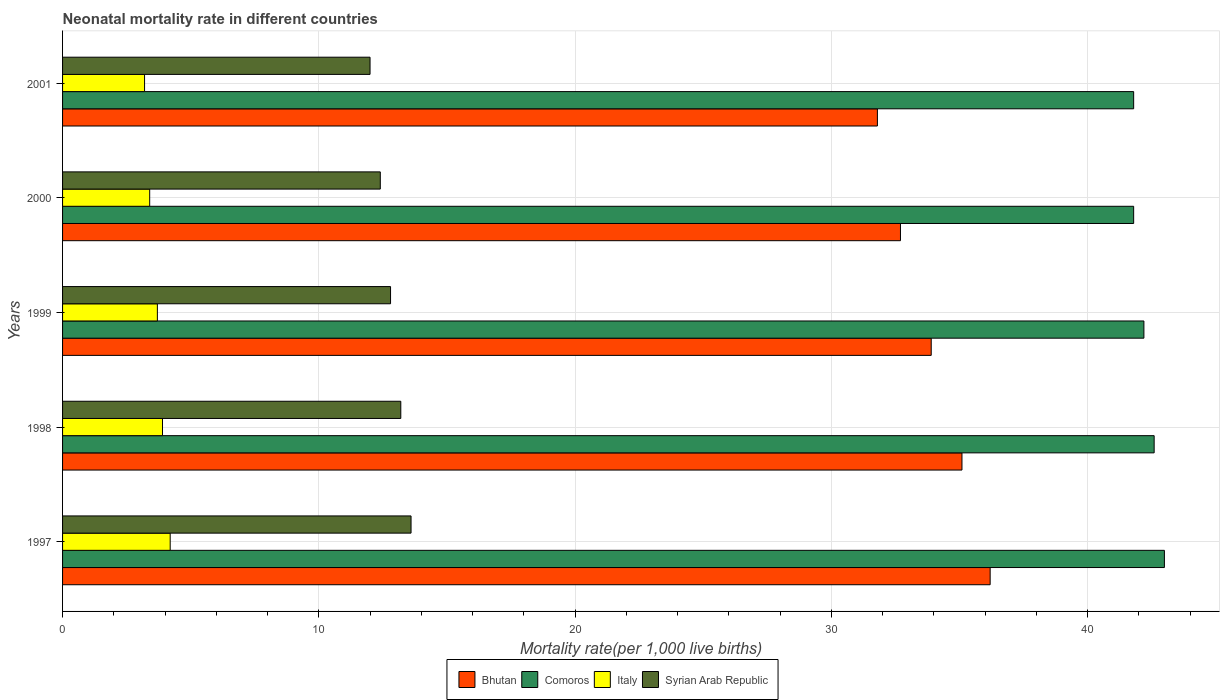How many different coloured bars are there?
Your answer should be very brief. 4. How many groups of bars are there?
Offer a very short reply. 5. Are the number of bars per tick equal to the number of legend labels?
Provide a short and direct response. Yes. How many bars are there on the 3rd tick from the bottom?
Give a very brief answer. 4. What is the label of the 2nd group of bars from the top?
Provide a succinct answer. 2000. What is the neonatal mortality rate in Comoros in 2001?
Keep it short and to the point. 41.8. Across all years, what is the maximum neonatal mortality rate in Italy?
Ensure brevity in your answer.  4.2. Across all years, what is the minimum neonatal mortality rate in Bhutan?
Your response must be concise. 31.8. In which year was the neonatal mortality rate in Syrian Arab Republic maximum?
Give a very brief answer. 1997. In which year was the neonatal mortality rate in Italy minimum?
Ensure brevity in your answer.  2001. What is the total neonatal mortality rate in Comoros in the graph?
Ensure brevity in your answer.  211.4. What is the difference between the neonatal mortality rate in Bhutan in 1997 and that in 1999?
Give a very brief answer. 2.3. What is the difference between the neonatal mortality rate in Bhutan in 1997 and the neonatal mortality rate in Syrian Arab Republic in 2001?
Give a very brief answer. 24.2. What is the average neonatal mortality rate in Syrian Arab Republic per year?
Ensure brevity in your answer.  12.8. In the year 1998, what is the difference between the neonatal mortality rate in Bhutan and neonatal mortality rate in Comoros?
Your response must be concise. -7.5. What is the ratio of the neonatal mortality rate in Comoros in 1998 to that in 2001?
Ensure brevity in your answer.  1.02. What is the difference between the highest and the second highest neonatal mortality rate in Bhutan?
Provide a short and direct response. 1.1. What is the difference between the highest and the lowest neonatal mortality rate in Comoros?
Offer a very short reply. 1.2. In how many years, is the neonatal mortality rate in Syrian Arab Republic greater than the average neonatal mortality rate in Syrian Arab Republic taken over all years?
Make the answer very short. 3. What does the 1st bar from the top in 1998 represents?
Offer a terse response. Syrian Arab Republic. What does the 1st bar from the bottom in 2001 represents?
Your response must be concise. Bhutan. How many bars are there?
Keep it short and to the point. 20. Are all the bars in the graph horizontal?
Provide a succinct answer. Yes. Are the values on the major ticks of X-axis written in scientific E-notation?
Keep it short and to the point. No. Does the graph contain grids?
Make the answer very short. Yes. Where does the legend appear in the graph?
Make the answer very short. Bottom center. What is the title of the graph?
Offer a terse response. Neonatal mortality rate in different countries. Does "Moldova" appear as one of the legend labels in the graph?
Offer a very short reply. No. What is the label or title of the X-axis?
Make the answer very short. Mortality rate(per 1,0 live births). What is the label or title of the Y-axis?
Make the answer very short. Years. What is the Mortality rate(per 1,000 live births) of Bhutan in 1997?
Make the answer very short. 36.2. What is the Mortality rate(per 1,000 live births) in Italy in 1997?
Give a very brief answer. 4.2. What is the Mortality rate(per 1,000 live births) of Syrian Arab Republic in 1997?
Your answer should be compact. 13.6. What is the Mortality rate(per 1,000 live births) of Bhutan in 1998?
Give a very brief answer. 35.1. What is the Mortality rate(per 1,000 live births) of Comoros in 1998?
Give a very brief answer. 42.6. What is the Mortality rate(per 1,000 live births) of Italy in 1998?
Ensure brevity in your answer.  3.9. What is the Mortality rate(per 1,000 live births) of Bhutan in 1999?
Offer a very short reply. 33.9. What is the Mortality rate(per 1,000 live births) in Comoros in 1999?
Your answer should be very brief. 42.2. What is the Mortality rate(per 1,000 live births) of Syrian Arab Republic in 1999?
Provide a short and direct response. 12.8. What is the Mortality rate(per 1,000 live births) in Bhutan in 2000?
Your answer should be compact. 32.7. What is the Mortality rate(per 1,000 live births) of Comoros in 2000?
Make the answer very short. 41.8. What is the Mortality rate(per 1,000 live births) in Italy in 2000?
Ensure brevity in your answer.  3.4. What is the Mortality rate(per 1,000 live births) in Bhutan in 2001?
Give a very brief answer. 31.8. What is the Mortality rate(per 1,000 live births) of Comoros in 2001?
Make the answer very short. 41.8. What is the Mortality rate(per 1,000 live births) in Syrian Arab Republic in 2001?
Provide a succinct answer. 12. Across all years, what is the maximum Mortality rate(per 1,000 live births) in Bhutan?
Provide a short and direct response. 36.2. Across all years, what is the maximum Mortality rate(per 1,000 live births) in Comoros?
Your response must be concise. 43. Across all years, what is the maximum Mortality rate(per 1,000 live births) in Italy?
Your answer should be very brief. 4.2. Across all years, what is the minimum Mortality rate(per 1,000 live births) of Bhutan?
Your response must be concise. 31.8. Across all years, what is the minimum Mortality rate(per 1,000 live births) in Comoros?
Give a very brief answer. 41.8. What is the total Mortality rate(per 1,000 live births) in Bhutan in the graph?
Keep it short and to the point. 169.7. What is the total Mortality rate(per 1,000 live births) in Comoros in the graph?
Keep it short and to the point. 211.4. What is the total Mortality rate(per 1,000 live births) in Syrian Arab Republic in the graph?
Offer a very short reply. 64. What is the difference between the Mortality rate(per 1,000 live births) of Syrian Arab Republic in 1997 and that in 1998?
Make the answer very short. 0.4. What is the difference between the Mortality rate(per 1,000 live births) of Comoros in 1997 and that in 1999?
Offer a very short reply. 0.8. What is the difference between the Mortality rate(per 1,000 live births) in Bhutan in 1997 and that in 2000?
Offer a very short reply. 3.5. What is the difference between the Mortality rate(per 1,000 live births) of Comoros in 1997 and that in 2000?
Provide a succinct answer. 1.2. What is the difference between the Mortality rate(per 1,000 live births) of Italy in 1997 and that in 2001?
Your answer should be compact. 1. What is the difference between the Mortality rate(per 1,000 live births) of Italy in 1998 and that in 1999?
Your response must be concise. 0.2. What is the difference between the Mortality rate(per 1,000 live births) in Syrian Arab Republic in 1998 and that in 1999?
Your answer should be very brief. 0.4. What is the difference between the Mortality rate(per 1,000 live births) in Bhutan in 1998 and that in 2000?
Give a very brief answer. 2.4. What is the difference between the Mortality rate(per 1,000 live births) in Comoros in 1998 and that in 2000?
Your response must be concise. 0.8. What is the difference between the Mortality rate(per 1,000 live births) of Italy in 1998 and that in 2000?
Provide a short and direct response. 0.5. What is the difference between the Mortality rate(per 1,000 live births) of Comoros in 1998 and that in 2001?
Offer a very short reply. 0.8. What is the difference between the Mortality rate(per 1,000 live births) of Italy in 1998 and that in 2001?
Give a very brief answer. 0.7. What is the difference between the Mortality rate(per 1,000 live births) in Bhutan in 1999 and that in 2000?
Your response must be concise. 1.2. What is the difference between the Mortality rate(per 1,000 live births) of Italy in 1999 and that in 2000?
Keep it short and to the point. 0.3. What is the difference between the Mortality rate(per 1,000 live births) in Bhutan in 1999 and that in 2001?
Your answer should be compact. 2.1. What is the difference between the Mortality rate(per 1,000 live births) of Comoros in 2000 and that in 2001?
Keep it short and to the point. 0. What is the difference between the Mortality rate(per 1,000 live births) in Syrian Arab Republic in 2000 and that in 2001?
Give a very brief answer. 0.4. What is the difference between the Mortality rate(per 1,000 live births) of Bhutan in 1997 and the Mortality rate(per 1,000 live births) of Italy in 1998?
Give a very brief answer. 32.3. What is the difference between the Mortality rate(per 1,000 live births) of Comoros in 1997 and the Mortality rate(per 1,000 live births) of Italy in 1998?
Ensure brevity in your answer.  39.1. What is the difference between the Mortality rate(per 1,000 live births) of Comoros in 1997 and the Mortality rate(per 1,000 live births) of Syrian Arab Republic in 1998?
Provide a short and direct response. 29.8. What is the difference between the Mortality rate(per 1,000 live births) in Bhutan in 1997 and the Mortality rate(per 1,000 live births) in Comoros in 1999?
Ensure brevity in your answer.  -6. What is the difference between the Mortality rate(per 1,000 live births) of Bhutan in 1997 and the Mortality rate(per 1,000 live births) of Italy in 1999?
Keep it short and to the point. 32.5. What is the difference between the Mortality rate(per 1,000 live births) of Bhutan in 1997 and the Mortality rate(per 1,000 live births) of Syrian Arab Republic in 1999?
Your response must be concise. 23.4. What is the difference between the Mortality rate(per 1,000 live births) of Comoros in 1997 and the Mortality rate(per 1,000 live births) of Italy in 1999?
Offer a very short reply. 39.3. What is the difference between the Mortality rate(per 1,000 live births) in Comoros in 1997 and the Mortality rate(per 1,000 live births) in Syrian Arab Republic in 1999?
Your answer should be very brief. 30.2. What is the difference between the Mortality rate(per 1,000 live births) in Italy in 1997 and the Mortality rate(per 1,000 live births) in Syrian Arab Republic in 1999?
Provide a succinct answer. -8.6. What is the difference between the Mortality rate(per 1,000 live births) of Bhutan in 1997 and the Mortality rate(per 1,000 live births) of Italy in 2000?
Keep it short and to the point. 32.8. What is the difference between the Mortality rate(per 1,000 live births) of Bhutan in 1997 and the Mortality rate(per 1,000 live births) of Syrian Arab Republic in 2000?
Ensure brevity in your answer.  23.8. What is the difference between the Mortality rate(per 1,000 live births) of Comoros in 1997 and the Mortality rate(per 1,000 live births) of Italy in 2000?
Keep it short and to the point. 39.6. What is the difference between the Mortality rate(per 1,000 live births) of Comoros in 1997 and the Mortality rate(per 1,000 live births) of Syrian Arab Republic in 2000?
Ensure brevity in your answer.  30.6. What is the difference between the Mortality rate(per 1,000 live births) in Italy in 1997 and the Mortality rate(per 1,000 live births) in Syrian Arab Republic in 2000?
Your response must be concise. -8.2. What is the difference between the Mortality rate(per 1,000 live births) of Bhutan in 1997 and the Mortality rate(per 1,000 live births) of Syrian Arab Republic in 2001?
Keep it short and to the point. 24.2. What is the difference between the Mortality rate(per 1,000 live births) in Comoros in 1997 and the Mortality rate(per 1,000 live births) in Italy in 2001?
Your response must be concise. 39.8. What is the difference between the Mortality rate(per 1,000 live births) of Comoros in 1997 and the Mortality rate(per 1,000 live births) of Syrian Arab Republic in 2001?
Your response must be concise. 31. What is the difference between the Mortality rate(per 1,000 live births) in Italy in 1997 and the Mortality rate(per 1,000 live births) in Syrian Arab Republic in 2001?
Offer a very short reply. -7.8. What is the difference between the Mortality rate(per 1,000 live births) in Bhutan in 1998 and the Mortality rate(per 1,000 live births) in Italy in 1999?
Offer a very short reply. 31.4. What is the difference between the Mortality rate(per 1,000 live births) in Bhutan in 1998 and the Mortality rate(per 1,000 live births) in Syrian Arab Republic in 1999?
Provide a succinct answer. 22.3. What is the difference between the Mortality rate(per 1,000 live births) in Comoros in 1998 and the Mortality rate(per 1,000 live births) in Italy in 1999?
Provide a short and direct response. 38.9. What is the difference between the Mortality rate(per 1,000 live births) in Comoros in 1998 and the Mortality rate(per 1,000 live births) in Syrian Arab Republic in 1999?
Your answer should be compact. 29.8. What is the difference between the Mortality rate(per 1,000 live births) in Italy in 1998 and the Mortality rate(per 1,000 live births) in Syrian Arab Republic in 1999?
Your answer should be very brief. -8.9. What is the difference between the Mortality rate(per 1,000 live births) in Bhutan in 1998 and the Mortality rate(per 1,000 live births) in Italy in 2000?
Provide a succinct answer. 31.7. What is the difference between the Mortality rate(per 1,000 live births) in Bhutan in 1998 and the Mortality rate(per 1,000 live births) in Syrian Arab Republic in 2000?
Make the answer very short. 22.7. What is the difference between the Mortality rate(per 1,000 live births) of Comoros in 1998 and the Mortality rate(per 1,000 live births) of Italy in 2000?
Ensure brevity in your answer.  39.2. What is the difference between the Mortality rate(per 1,000 live births) of Comoros in 1998 and the Mortality rate(per 1,000 live births) of Syrian Arab Republic in 2000?
Ensure brevity in your answer.  30.2. What is the difference between the Mortality rate(per 1,000 live births) of Italy in 1998 and the Mortality rate(per 1,000 live births) of Syrian Arab Republic in 2000?
Your answer should be very brief. -8.5. What is the difference between the Mortality rate(per 1,000 live births) in Bhutan in 1998 and the Mortality rate(per 1,000 live births) in Comoros in 2001?
Provide a short and direct response. -6.7. What is the difference between the Mortality rate(per 1,000 live births) of Bhutan in 1998 and the Mortality rate(per 1,000 live births) of Italy in 2001?
Provide a short and direct response. 31.9. What is the difference between the Mortality rate(per 1,000 live births) of Bhutan in 1998 and the Mortality rate(per 1,000 live births) of Syrian Arab Republic in 2001?
Offer a terse response. 23.1. What is the difference between the Mortality rate(per 1,000 live births) of Comoros in 1998 and the Mortality rate(per 1,000 live births) of Italy in 2001?
Offer a very short reply. 39.4. What is the difference between the Mortality rate(per 1,000 live births) of Comoros in 1998 and the Mortality rate(per 1,000 live births) of Syrian Arab Republic in 2001?
Offer a very short reply. 30.6. What is the difference between the Mortality rate(per 1,000 live births) of Bhutan in 1999 and the Mortality rate(per 1,000 live births) of Italy in 2000?
Offer a terse response. 30.5. What is the difference between the Mortality rate(per 1,000 live births) in Bhutan in 1999 and the Mortality rate(per 1,000 live births) in Syrian Arab Republic in 2000?
Offer a very short reply. 21.5. What is the difference between the Mortality rate(per 1,000 live births) of Comoros in 1999 and the Mortality rate(per 1,000 live births) of Italy in 2000?
Ensure brevity in your answer.  38.8. What is the difference between the Mortality rate(per 1,000 live births) in Comoros in 1999 and the Mortality rate(per 1,000 live births) in Syrian Arab Republic in 2000?
Your response must be concise. 29.8. What is the difference between the Mortality rate(per 1,000 live births) in Bhutan in 1999 and the Mortality rate(per 1,000 live births) in Comoros in 2001?
Provide a short and direct response. -7.9. What is the difference between the Mortality rate(per 1,000 live births) of Bhutan in 1999 and the Mortality rate(per 1,000 live births) of Italy in 2001?
Keep it short and to the point. 30.7. What is the difference between the Mortality rate(per 1,000 live births) in Bhutan in 1999 and the Mortality rate(per 1,000 live births) in Syrian Arab Republic in 2001?
Ensure brevity in your answer.  21.9. What is the difference between the Mortality rate(per 1,000 live births) in Comoros in 1999 and the Mortality rate(per 1,000 live births) in Italy in 2001?
Offer a terse response. 39. What is the difference between the Mortality rate(per 1,000 live births) in Comoros in 1999 and the Mortality rate(per 1,000 live births) in Syrian Arab Republic in 2001?
Provide a short and direct response. 30.2. What is the difference between the Mortality rate(per 1,000 live births) of Italy in 1999 and the Mortality rate(per 1,000 live births) of Syrian Arab Republic in 2001?
Your response must be concise. -8.3. What is the difference between the Mortality rate(per 1,000 live births) in Bhutan in 2000 and the Mortality rate(per 1,000 live births) in Comoros in 2001?
Provide a short and direct response. -9.1. What is the difference between the Mortality rate(per 1,000 live births) in Bhutan in 2000 and the Mortality rate(per 1,000 live births) in Italy in 2001?
Give a very brief answer. 29.5. What is the difference between the Mortality rate(per 1,000 live births) of Bhutan in 2000 and the Mortality rate(per 1,000 live births) of Syrian Arab Republic in 2001?
Offer a terse response. 20.7. What is the difference between the Mortality rate(per 1,000 live births) of Comoros in 2000 and the Mortality rate(per 1,000 live births) of Italy in 2001?
Ensure brevity in your answer.  38.6. What is the difference between the Mortality rate(per 1,000 live births) of Comoros in 2000 and the Mortality rate(per 1,000 live births) of Syrian Arab Republic in 2001?
Your response must be concise. 29.8. What is the average Mortality rate(per 1,000 live births) of Bhutan per year?
Your response must be concise. 33.94. What is the average Mortality rate(per 1,000 live births) in Comoros per year?
Keep it short and to the point. 42.28. What is the average Mortality rate(per 1,000 live births) in Italy per year?
Offer a terse response. 3.68. What is the average Mortality rate(per 1,000 live births) of Syrian Arab Republic per year?
Your answer should be very brief. 12.8. In the year 1997, what is the difference between the Mortality rate(per 1,000 live births) in Bhutan and Mortality rate(per 1,000 live births) in Comoros?
Offer a terse response. -6.8. In the year 1997, what is the difference between the Mortality rate(per 1,000 live births) in Bhutan and Mortality rate(per 1,000 live births) in Italy?
Offer a very short reply. 32. In the year 1997, what is the difference between the Mortality rate(per 1,000 live births) in Bhutan and Mortality rate(per 1,000 live births) in Syrian Arab Republic?
Provide a succinct answer. 22.6. In the year 1997, what is the difference between the Mortality rate(per 1,000 live births) of Comoros and Mortality rate(per 1,000 live births) of Italy?
Your answer should be very brief. 38.8. In the year 1997, what is the difference between the Mortality rate(per 1,000 live births) in Comoros and Mortality rate(per 1,000 live births) in Syrian Arab Republic?
Your answer should be compact. 29.4. In the year 1997, what is the difference between the Mortality rate(per 1,000 live births) in Italy and Mortality rate(per 1,000 live births) in Syrian Arab Republic?
Offer a very short reply. -9.4. In the year 1998, what is the difference between the Mortality rate(per 1,000 live births) of Bhutan and Mortality rate(per 1,000 live births) of Italy?
Keep it short and to the point. 31.2. In the year 1998, what is the difference between the Mortality rate(per 1,000 live births) of Bhutan and Mortality rate(per 1,000 live births) of Syrian Arab Republic?
Give a very brief answer. 21.9. In the year 1998, what is the difference between the Mortality rate(per 1,000 live births) of Comoros and Mortality rate(per 1,000 live births) of Italy?
Your response must be concise. 38.7. In the year 1998, what is the difference between the Mortality rate(per 1,000 live births) of Comoros and Mortality rate(per 1,000 live births) of Syrian Arab Republic?
Make the answer very short. 29.4. In the year 1998, what is the difference between the Mortality rate(per 1,000 live births) of Italy and Mortality rate(per 1,000 live births) of Syrian Arab Republic?
Your answer should be very brief. -9.3. In the year 1999, what is the difference between the Mortality rate(per 1,000 live births) in Bhutan and Mortality rate(per 1,000 live births) in Comoros?
Provide a short and direct response. -8.3. In the year 1999, what is the difference between the Mortality rate(per 1,000 live births) in Bhutan and Mortality rate(per 1,000 live births) in Italy?
Make the answer very short. 30.2. In the year 1999, what is the difference between the Mortality rate(per 1,000 live births) of Bhutan and Mortality rate(per 1,000 live births) of Syrian Arab Republic?
Your answer should be very brief. 21.1. In the year 1999, what is the difference between the Mortality rate(per 1,000 live births) of Comoros and Mortality rate(per 1,000 live births) of Italy?
Your answer should be very brief. 38.5. In the year 1999, what is the difference between the Mortality rate(per 1,000 live births) of Comoros and Mortality rate(per 1,000 live births) of Syrian Arab Republic?
Provide a short and direct response. 29.4. In the year 2000, what is the difference between the Mortality rate(per 1,000 live births) in Bhutan and Mortality rate(per 1,000 live births) in Italy?
Give a very brief answer. 29.3. In the year 2000, what is the difference between the Mortality rate(per 1,000 live births) of Bhutan and Mortality rate(per 1,000 live births) of Syrian Arab Republic?
Your response must be concise. 20.3. In the year 2000, what is the difference between the Mortality rate(per 1,000 live births) in Comoros and Mortality rate(per 1,000 live births) in Italy?
Give a very brief answer. 38.4. In the year 2000, what is the difference between the Mortality rate(per 1,000 live births) of Comoros and Mortality rate(per 1,000 live births) of Syrian Arab Republic?
Ensure brevity in your answer.  29.4. In the year 2000, what is the difference between the Mortality rate(per 1,000 live births) of Italy and Mortality rate(per 1,000 live births) of Syrian Arab Republic?
Your answer should be compact. -9. In the year 2001, what is the difference between the Mortality rate(per 1,000 live births) in Bhutan and Mortality rate(per 1,000 live births) in Italy?
Make the answer very short. 28.6. In the year 2001, what is the difference between the Mortality rate(per 1,000 live births) in Bhutan and Mortality rate(per 1,000 live births) in Syrian Arab Republic?
Ensure brevity in your answer.  19.8. In the year 2001, what is the difference between the Mortality rate(per 1,000 live births) of Comoros and Mortality rate(per 1,000 live births) of Italy?
Give a very brief answer. 38.6. In the year 2001, what is the difference between the Mortality rate(per 1,000 live births) in Comoros and Mortality rate(per 1,000 live births) in Syrian Arab Republic?
Give a very brief answer. 29.8. In the year 2001, what is the difference between the Mortality rate(per 1,000 live births) in Italy and Mortality rate(per 1,000 live births) in Syrian Arab Republic?
Your response must be concise. -8.8. What is the ratio of the Mortality rate(per 1,000 live births) in Bhutan in 1997 to that in 1998?
Provide a succinct answer. 1.03. What is the ratio of the Mortality rate(per 1,000 live births) of Comoros in 1997 to that in 1998?
Make the answer very short. 1.01. What is the ratio of the Mortality rate(per 1,000 live births) of Italy in 1997 to that in 1998?
Offer a very short reply. 1.08. What is the ratio of the Mortality rate(per 1,000 live births) of Syrian Arab Republic in 1997 to that in 1998?
Provide a short and direct response. 1.03. What is the ratio of the Mortality rate(per 1,000 live births) of Bhutan in 1997 to that in 1999?
Give a very brief answer. 1.07. What is the ratio of the Mortality rate(per 1,000 live births) in Italy in 1997 to that in 1999?
Offer a very short reply. 1.14. What is the ratio of the Mortality rate(per 1,000 live births) of Syrian Arab Republic in 1997 to that in 1999?
Your answer should be very brief. 1.06. What is the ratio of the Mortality rate(per 1,000 live births) of Bhutan in 1997 to that in 2000?
Offer a terse response. 1.11. What is the ratio of the Mortality rate(per 1,000 live births) of Comoros in 1997 to that in 2000?
Your answer should be very brief. 1.03. What is the ratio of the Mortality rate(per 1,000 live births) of Italy in 1997 to that in 2000?
Your answer should be compact. 1.24. What is the ratio of the Mortality rate(per 1,000 live births) of Syrian Arab Republic in 1997 to that in 2000?
Provide a short and direct response. 1.1. What is the ratio of the Mortality rate(per 1,000 live births) in Bhutan in 1997 to that in 2001?
Your response must be concise. 1.14. What is the ratio of the Mortality rate(per 1,000 live births) of Comoros in 1997 to that in 2001?
Provide a succinct answer. 1.03. What is the ratio of the Mortality rate(per 1,000 live births) in Italy in 1997 to that in 2001?
Provide a succinct answer. 1.31. What is the ratio of the Mortality rate(per 1,000 live births) in Syrian Arab Republic in 1997 to that in 2001?
Provide a short and direct response. 1.13. What is the ratio of the Mortality rate(per 1,000 live births) of Bhutan in 1998 to that in 1999?
Provide a succinct answer. 1.04. What is the ratio of the Mortality rate(per 1,000 live births) of Comoros in 1998 to that in 1999?
Keep it short and to the point. 1.01. What is the ratio of the Mortality rate(per 1,000 live births) in Italy in 1998 to that in 1999?
Your answer should be compact. 1.05. What is the ratio of the Mortality rate(per 1,000 live births) in Syrian Arab Republic in 1998 to that in 1999?
Keep it short and to the point. 1.03. What is the ratio of the Mortality rate(per 1,000 live births) of Bhutan in 1998 to that in 2000?
Your response must be concise. 1.07. What is the ratio of the Mortality rate(per 1,000 live births) in Comoros in 1998 to that in 2000?
Offer a very short reply. 1.02. What is the ratio of the Mortality rate(per 1,000 live births) in Italy in 1998 to that in 2000?
Your answer should be compact. 1.15. What is the ratio of the Mortality rate(per 1,000 live births) of Syrian Arab Republic in 1998 to that in 2000?
Offer a terse response. 1.06. What is the ratio of the Mortality rate(per 1,000 live births) of Bhutan in 1998 to that in 2001?
Offer a terse response. 1.1. What is the ratio of the Mortality rate(per 1,000 live births) in Comoros in 1998 to that in 2001?
Your answer should be very brief. 1.02. What is the ratio of the Mortality rate(per 1,000 live births) of Italy in 1998 to that in 2001?
Offer a very short reply. 1.22. What is the ratio of the Mortality rate(per 1,000 live births) in Syrian Arab Republic in 1998 to that in 2001?
Offer a terse response. 1.1. What is the ratio of the Mortality rate(per 1,000 live births) of Bhutan in 1999 to that in 2000?
Provide a succinct answer. 1.04. What is the ratio of the Mortality rate(per 1,000 live births) of Comoros in 1999 to that in 2000?
Offer a very short reply. 1.01. What is the ratio of the Mortality rate(per 1,000 live births) in Italy in 1999 to that in 2000?
Ensure brevity in your answer.  1.09. What is the ratio of the Mortality rate(per 1,000 live births) in Syrian Arab Republic in 1999 to that in 2000?
Make the answer very short. 1.03. What is the ratio of the Mortality rate(per 1,000 live births) of Bhutan in 1999 to that in 2001?
Provide a succinct answer. 1.07. What is the ratio of the Mortality rate(per 1,000 live births) of Comoros in 1999 to that in 2001?
Your answer should be very brief. 1.01. What is the ratio of the Mortality rate(per 1,000 live births) of Italy in 1999 to that in 2001?
Make the answer very short. 1.16. What is the ratio of the Mortality rate(per 1,000 live births) in Syrian Arab Republic in 1999 to that in 2001?
Provide a short and direct response. 1.07. What is the ratio of the Mortality rate(per 1,000 live births) of Bhutan in 2000 to that in 2001?
Make the answer very short. 1.03. What is the ratio of the Mortality rate(per 1,000 live births) in Comoros in 2000 to that in 2001?
Your answer should be very brief. 1. What is the ratio of the Mortality rate(per 1,000 live births) of Syrian Arab Republic in 2000 to that in 2001?
Provide a succinct answer. 1.03. What is the difference between the highest and the second highest Mortality rate(per 1,000 live births) in Bhutan?
Your response must be concise. 1.1. What is the difference between the highest and the second highest Mortality rate(per 1,000 live births) of Comoros?
Give a very brief answer. 0.4. What is the difference between the highest and the second highest Mortality rate(per 1,000 live births) of Syrian Arab Republic?
Your answer should be compact. 0.4. What is the difference between the highest and the lowest Mortality rate(per 1,000 live births) of Bhutan?
Provide a succinct answer. 4.4. What is the difference between the highest and the lowest Mortality rate(per 1,000 live births) in Comoros?
Give a very brief answer. 1.2. What is the difference between the highest and the lowest Mortality rate(per 1,000 live births) in Italy?
Provide a succinct answer. 1. 